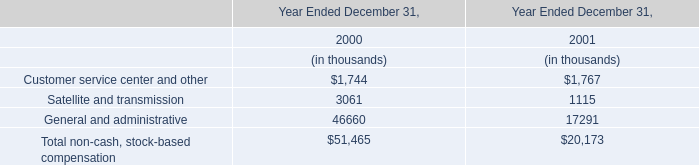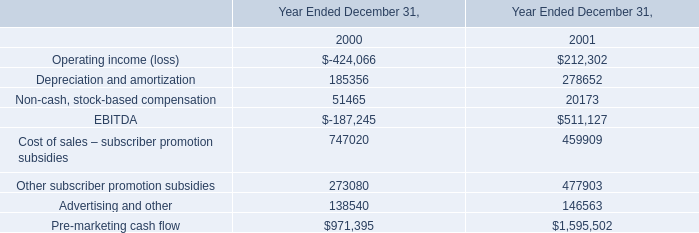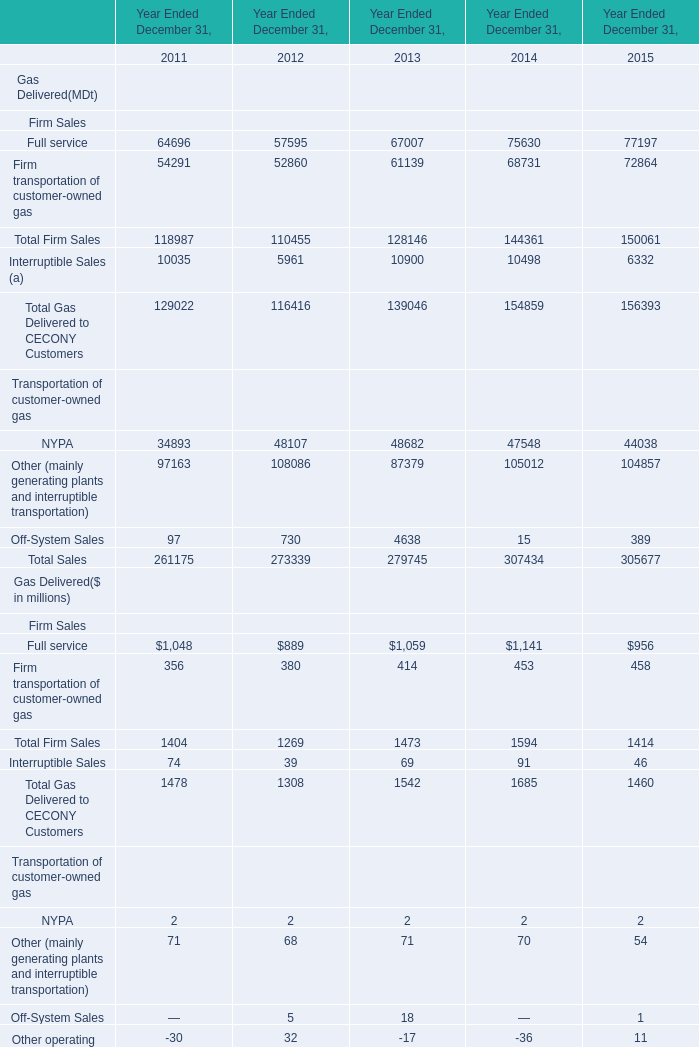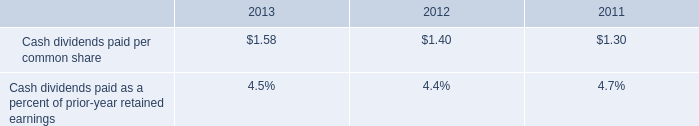What is the sum of the total sales in the years where Total Firm Sales is greater than 150000? (in million) 
Computations: ((((150061 + 6332) + 44038) + 104857) + 389)
Answer: 305677.0. 